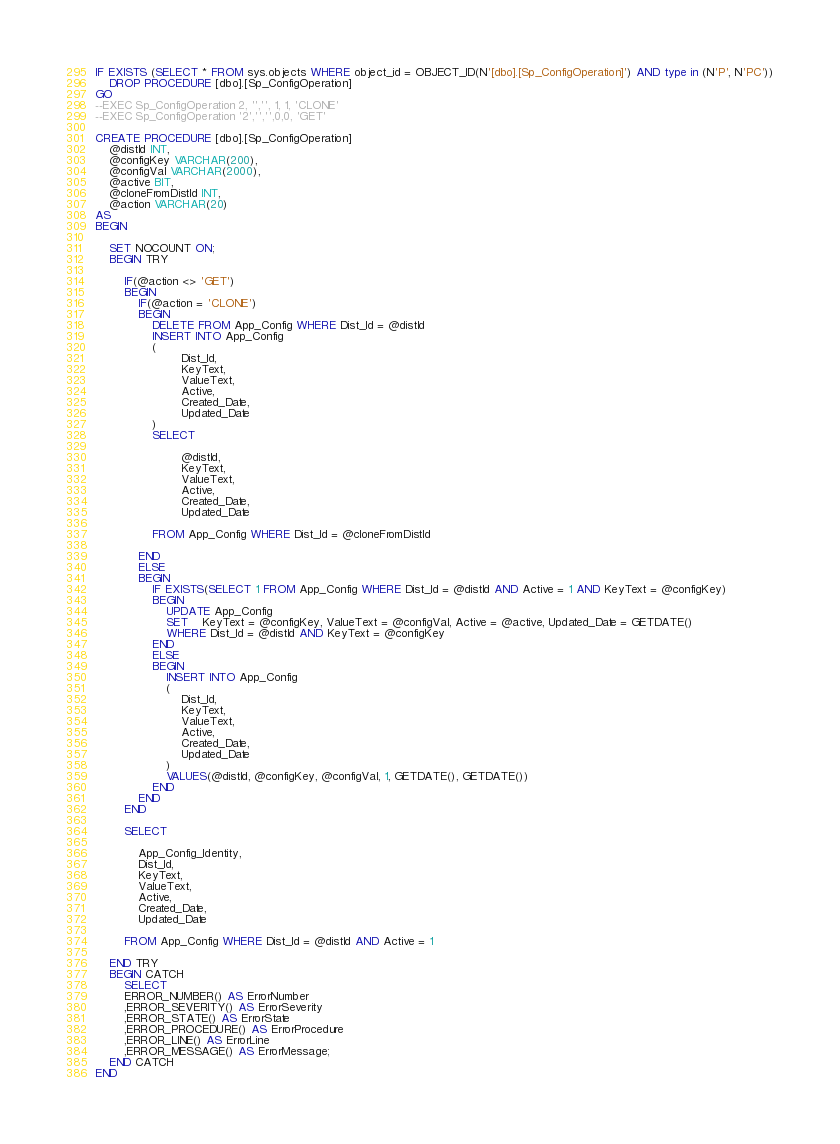Convert code to text. <code><loc_0><loc_0><loc_500><loc_500><_SQL_>IF EXISTS (SELECT * FROM sys.objects WHERE object_id = OBJECT_ID(N'[dbo].[Sp_ConfigOperation]') AND type in (N'P', N'PC'))
	DROP PROCEDURE [dbo].[Sp_ConfigOperation]
GO
--EXEC Sp_ConfigOperation 2, '','', 1, 1, 'CLONE'
--EXEC Sp_ConfigOperation '2','','',0,0, 'GET'

CREATE PROCEDURE [dbo].[Sp_ConfigOperation]
	@distId INT,
	@configKey VARCHAR(200),
	@configVal VARCHAR(2000),
	@active BIT,
	@cloneFromDistId INT,
	@action VARCHAR(20)
AS
BEGIN
	
	SET NOCOUNT ON;	
	BEGIN TRY
		
		IF(@action <> 'GET')
		BEGIN
			IF(@action = 'CLONE')
			BEGIN
				DELETE FROM App_Config WHERE Dist_Id = @distId
				INSERT INTO App_Config
				(
						Dist_Id,
						KeyText,
						ValueText,
						Active,
						Created_Date,
						Updated_Date
				)
				SELECT 
								
						@distId,
						KeyText,
						ValueText,
						Active,
						Created_Date,
						Updated_Date
				
				FROM App_Config WHERE Dist_Id = @cloneFromDistId
					
			END
			ELSE
			BEGIN
				IF EXISTS(SELECT 1 FROM App_Config WHERE Dist_Id = @distId AND Active = 1 AND KeyText = @configKey)
				BEGIN
					UPDATE App_Config
					SET	KeyText = @configKey, ValueText = @configVal, Active = @active, Updated_Date = GETDATE()
					WHERE Dist_Id = @distId AND KeyText = @configKey
				END
				ELSE
				BEGIN
					INSERT INTO App_Config
					(
						Dist_Id,
						KeyText,
						ValueText,
						Active,
						Created_Date,
						Updated_Date
					)
					VALUES(@distId, @configKey, @configVal, 1, GETDATE(), GETDATE())
				END
			END
		END

		SELECT 
		
			App_Config_Identity,
			Dist_Id,
			KeyText,
			ValueText,
			Active,
			Created_Date,
			Updated_Date 

		FROM App_Config WHERE Dist_Id = @distId AND Active = 1

	END TRY
	BEGIN CATCH
		SELECT  
		ERROR_NUMBER() AS ErrorNumber  
		,ERROR_SEVERITY() AS ErrorSeverity  
		,ERROR_STATE() AS ErrorState  
		,ERROR_PROCEDURE() AS ErrorProcedure  
		,ERROR_LINE() AS ErrorLine  
		,ERROR_MESSAGE() AS ErrorMessage;  
	END CATCH
END

</code> 